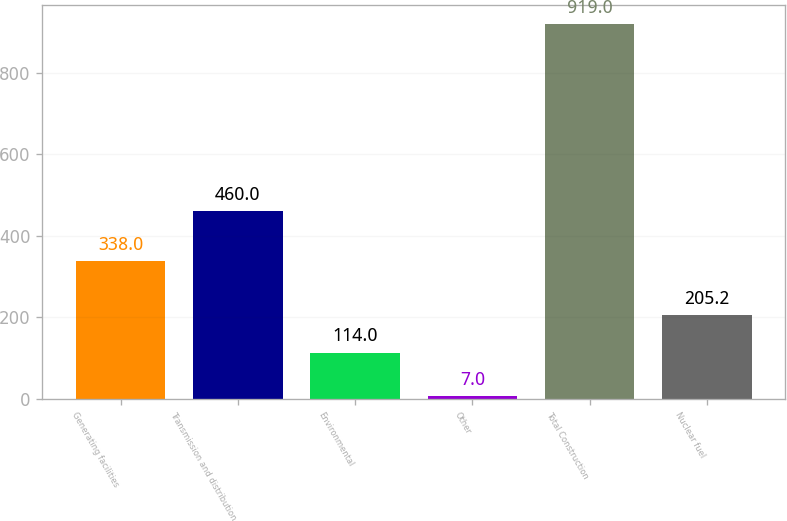Convert chart to OTSL. <chart><loc_0><loc_0><loc_500><loc_500><bar_chart><fcel>Generating facilities<fcel>Transmission and distribution<fcel>Environmental<fcel>Other<fcel>Total Construction<fcel>Nuclear fuel<nl><fcel>338<fcel>460<fcel>114<fcel>7<fcel>919<fcel>205.2<nl></chart> 